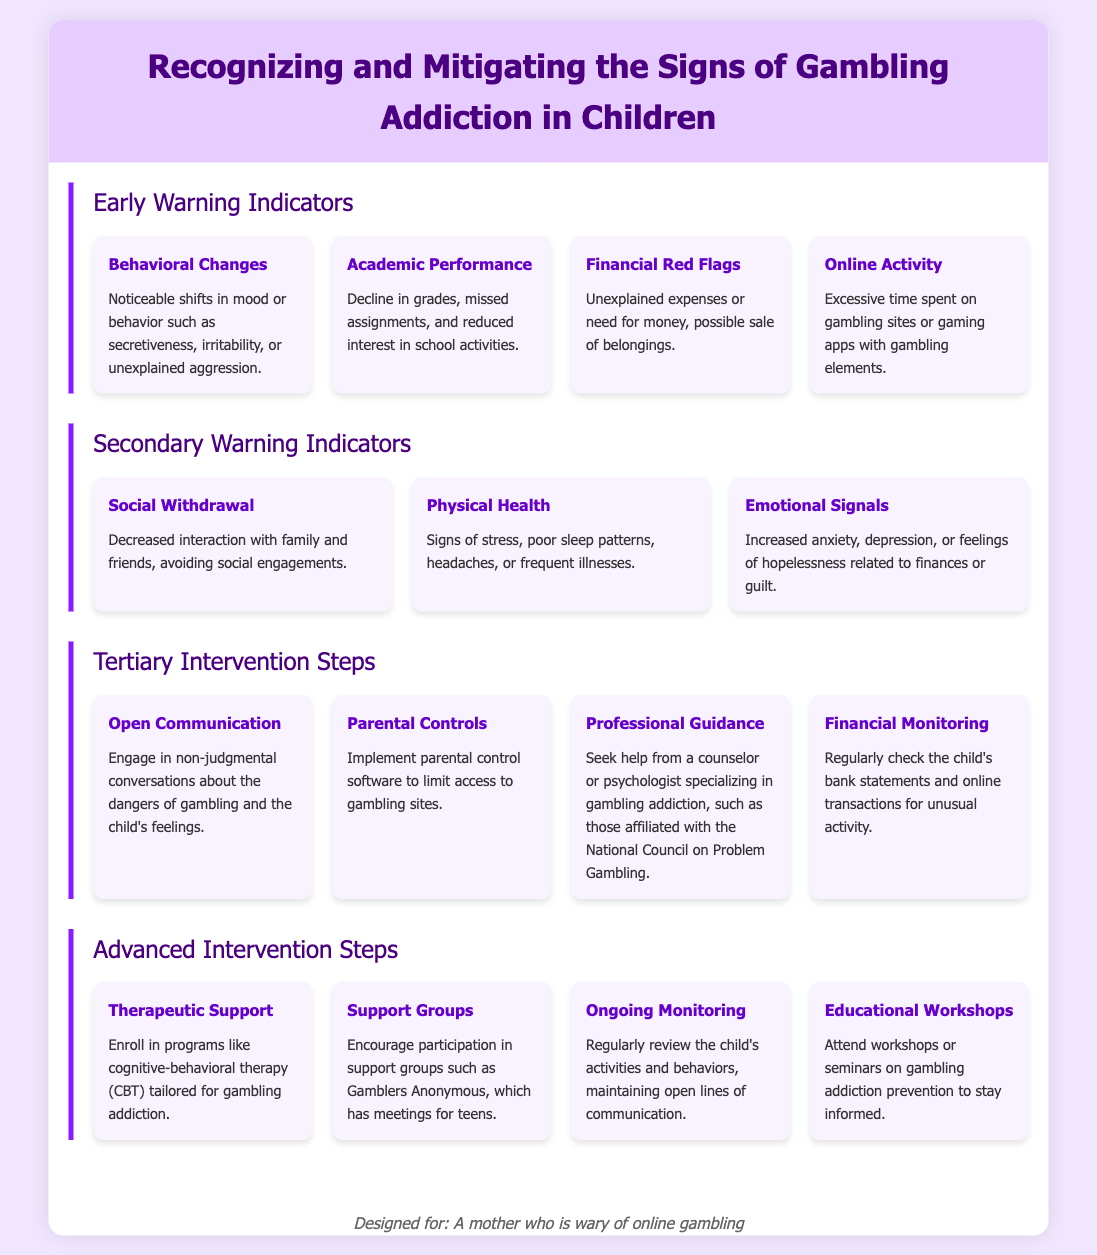What are early warning indicators of gambling addiction? The early warning indicators listed in the document include behavioral changes, academic performance, financial red flags, and online activity.
Answer: behavioral changes, academic performance, financial red flags, online activity What is one emotional signal related to gambling addiction? The document mentions increased anxiety, depression, or feelings of hopelessness as emotional signals.
Answer: increased anxiety What step involves engaging in conversations about gambling? The step that involves this action is "Open Communication."
Answer: Open Communication Which therapeutic approach is suggested for gambling addiction? The document recommends cognitive-behavioral therapy (CBT) tailored for gambling addiction.
Answer: cognitive-behavioral therapy (CBT) What should parents monitor to detect financial red flags? Parents should regularly check the child's bank statements and online transactions.
Answer: child's bank statements and online transactions What is a sign of physical health issues associated with gambling addiction? Signs include poor sleep patterns and frequent illnesses.
Answer: poor sleep patterns How many advanced intervention steps are listed in the document? The document lists four advanced intervention steps.
Answer: four Which element discusses limiting access to gambling sites? The element that discusses this is "Parental Controls."
Answer: Parental Controls What does the support group Gamblers Anonymous offer? Gamblers Anonymous offers meetings for teens.
Answer: meetings for teens 